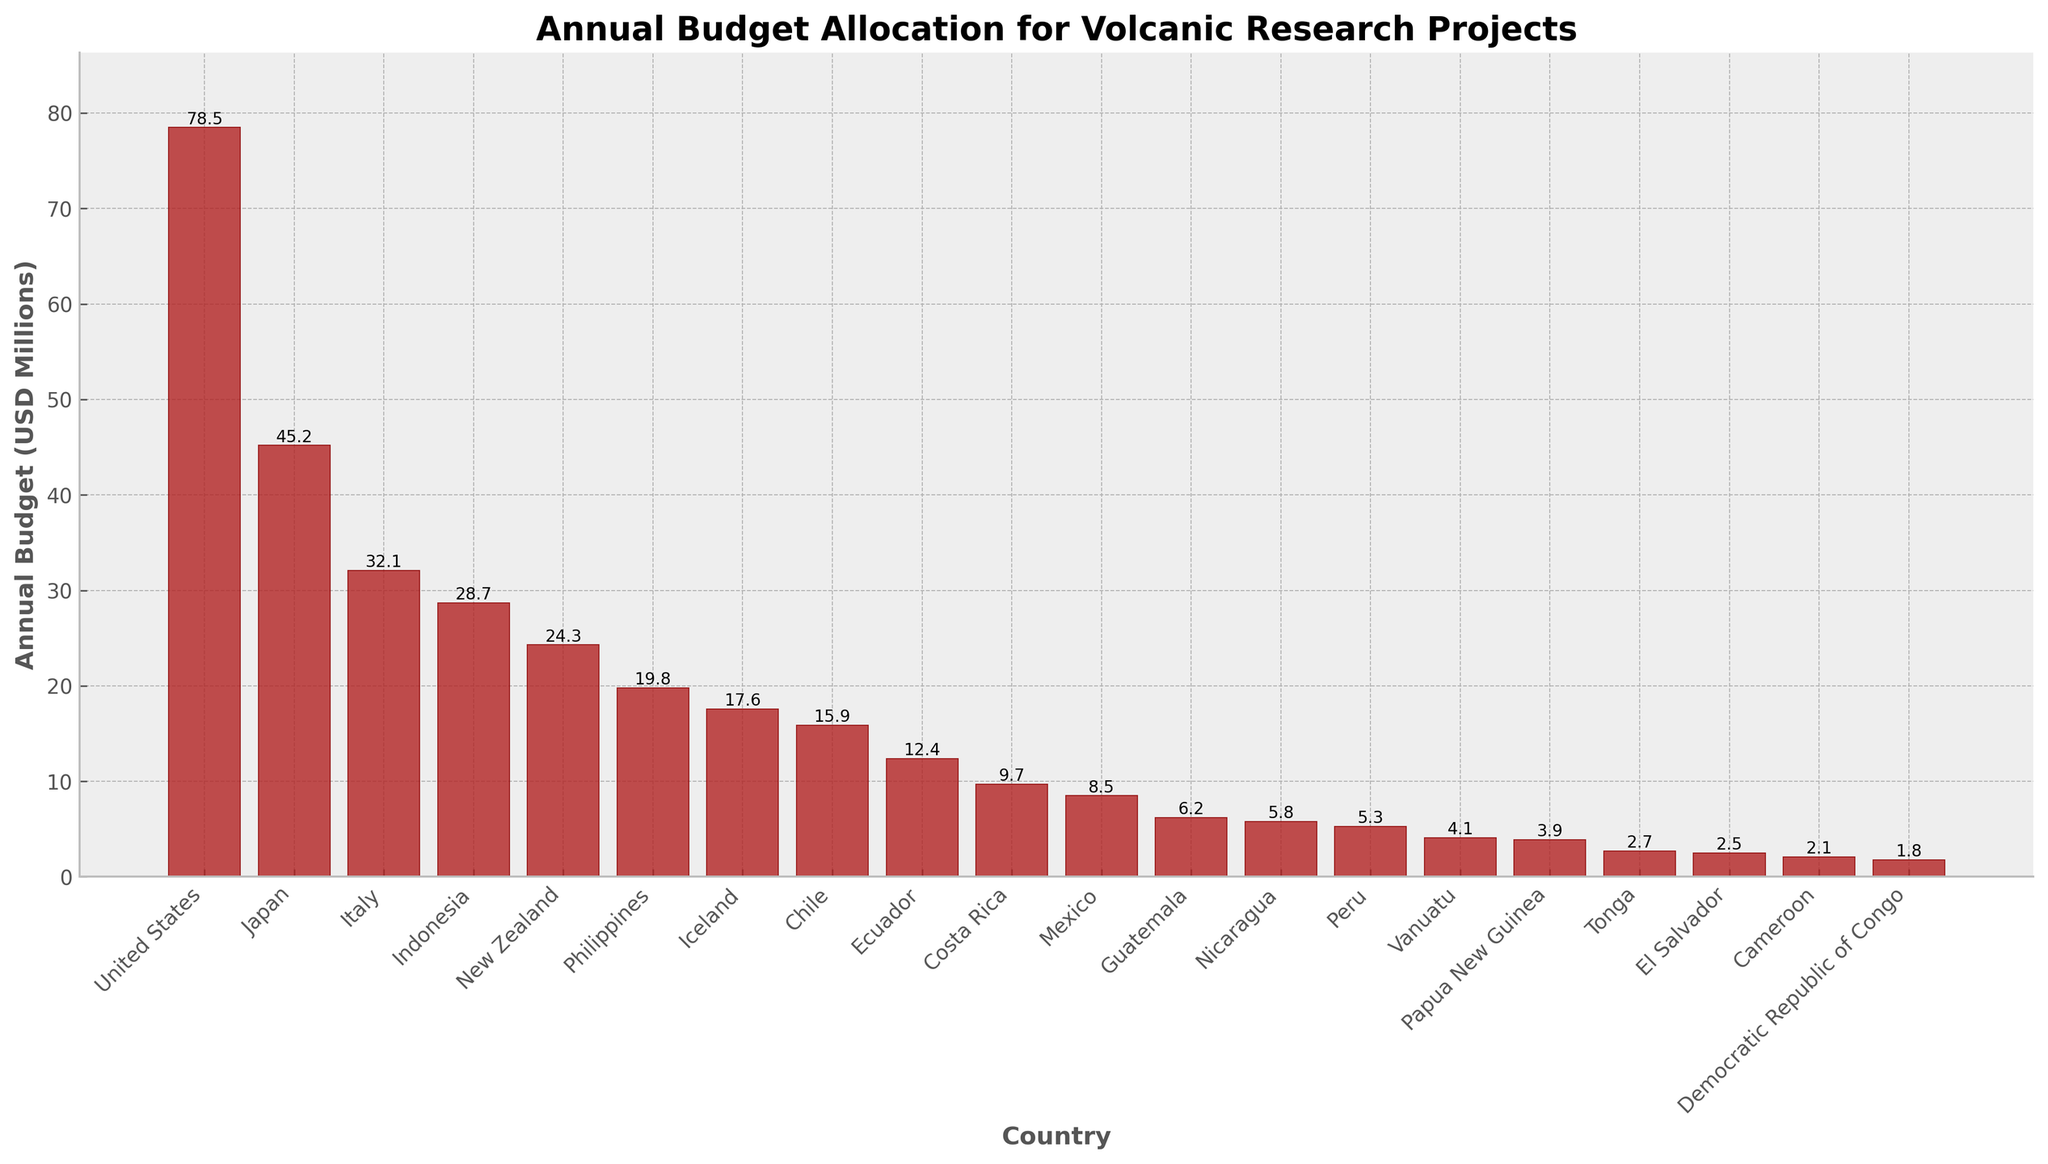Which country has the highest annual budget allocation for volcanic research projects? Look at the heights of the bars; the tallest bar represents the highest budget allocation. The United States has the highest budget allocation.
Answer: United States How much more is the annual budget for volcanic research in Japan compared to Italy? Subtract Italy's budget from Japan's budget. The budgets are 45.2 for Japan and 32.1 for Italy. 45.2 - 32.1 = 13.1
Answer: 13.1 million USD What is the total budget allocation for the top three countries combined? Add the budgets for the United States, Japan, and Italy. The values are 78.5, 45.2, and 32.1, respectively. Summing these gives 78.5 + 45.2 + 32.1 = 155.8
Answer: 155.8 million USD Which country has a lower budget allocation: Mexico or Chile? Compare the heights of the bars for Mexico and Chile. Mexico has a budget of 8.5 and Chile has a budget of 15.9. Mexico has a lower budget.
Answer: Mexico What is the difference in the budget allocations between the United States and Indonesia? Subtract Indonesia's budget from the United States' budget. The budgets are 78.5 for the United States and 28.7 for Indonesia. 78.5 - 28.7 = 49.8
Answer: 49.8 million USD How many countries have an annual budget allocation less than 10 million USD? Count the number of bars that are shorter than the mark for 10 million USD on the y-axis. There are seven countries: Costa Rica, Mexico, Guatemala, Nicaragua, Peru, Vanuatu, and Papua New Guinea.
Answer: 7 What is the average annual budget allocation for the countries shown in the figure? Add all the budget values and divide by the number of countries. Total budget = 78.5 + 45.2 + 32.1 + 28.7 + 24.3 + 19.8 + 17.6 + 15.9 + 12.4 + 9.7 + 8.5 + 6.2 + 5.8 + 5.3 + 4.1 + 3.9 + 2.7 + 2.5 + 2.1 + 1.8 = 357.1. Number of countries = 20. Average = 357.1 / 20 = 17.855
Answer: 17.855 million USD Which country has the second-lowest budget allocation? Find the second shortest bar in the chart. The shortest bar corresponds to the Democratic Republic of Congo with 1.8, and the second shortest is Cameroon with 2.1.
Answer: Cameroon Is the budget allocation for New Zealand higher or lower than that for Iceland? Compare the heights of the bars for New Zealand and Iceland. New Zealand has a budget of 24.3, while Iceland has a budget of 17.6. New Zealand has a higher budget.
Answer: Higher What is the combined budget for the Latin American countries listed (Chile, Ecuador, Costa Rica, Mexico, Guatemala, Nicaragua, Peru, El Salvador)? Add the budgets for these countries. The budgets are 15.9 (Chile), 12.4 (Ecuador), 9.7 (Costa Rica), 8.5 (Mexico), 6.2 (Guatemala), 5.8 (Nicaragua), 5.3 (Peru), and 2.5 (El Salvador). Sum = 15.9 + 12.4 + 9.7 + 8.5 + 6.2 + 5.8 + 5.3 + 2.5 = 66.3
Answer: 66.3 million USD 